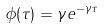Convert formula to latex. <formula><loc_0><loc_0><loc_500><loc_500>\phi ( \tau ) = \gamma e ^ { - \gamma \tau }</formula> 